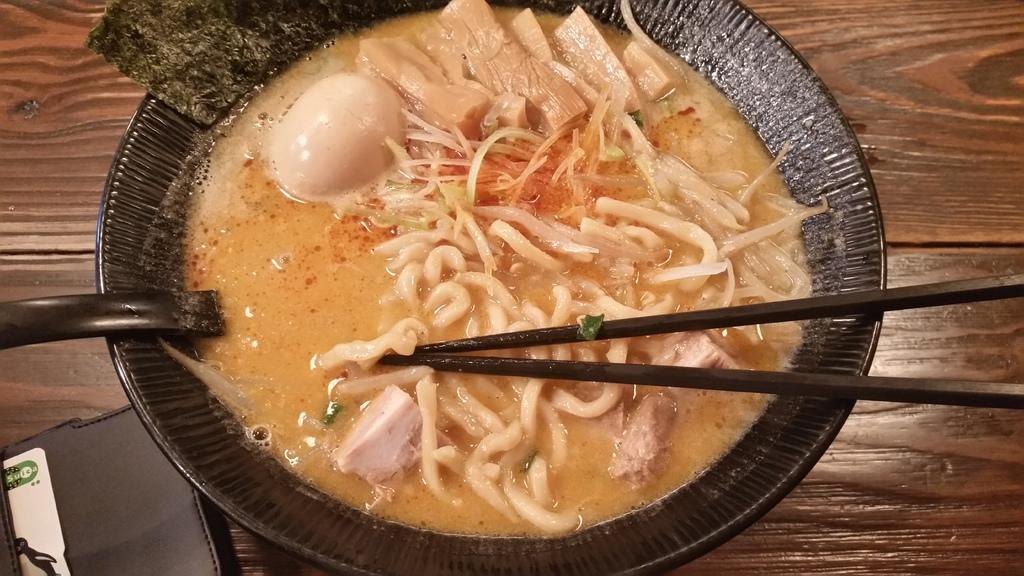What piece of furniture is present in the image? There is a table in the image. What is placed on the table? There is a plate of food on the table. What utensils are available for eating the food? There are chopsticks and a spoon on the table. What type of toothpaste is used to clean the root in the image? There is no toothpaste or root present in the image. 